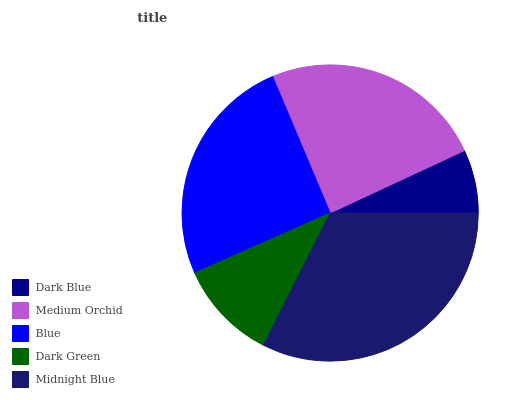Is Dark Blue the minimum?
Answer yes or no. Yes. Is Midnight Blue the maximum?
Answer yes or no. Yes. Is Medium Orchid the minimum?
Answer yes or no. No. Is Medium Orchid the maximum?
Answer yes or no. No. Is Medium Orchid greater than Dark Blue?
Answer yes or no. Yes. Is Dark Blue less than Medium Orchid?
Answer yes or no. Yes. Is Dark Blue greater than Medium Orchid?
Answer yes or no. No. Is Medium Orchid less than Dark Blue?
Answer yes or no. No. Is Medium Orchid the high median?
Answer yes or no. Yes. Is Medium Orchid the low median?
Answer yes or no. Yes. Is Blue the high median?
Answer yes or no. No. Is Dark Blue the low median?
Answer yes or no. No. 